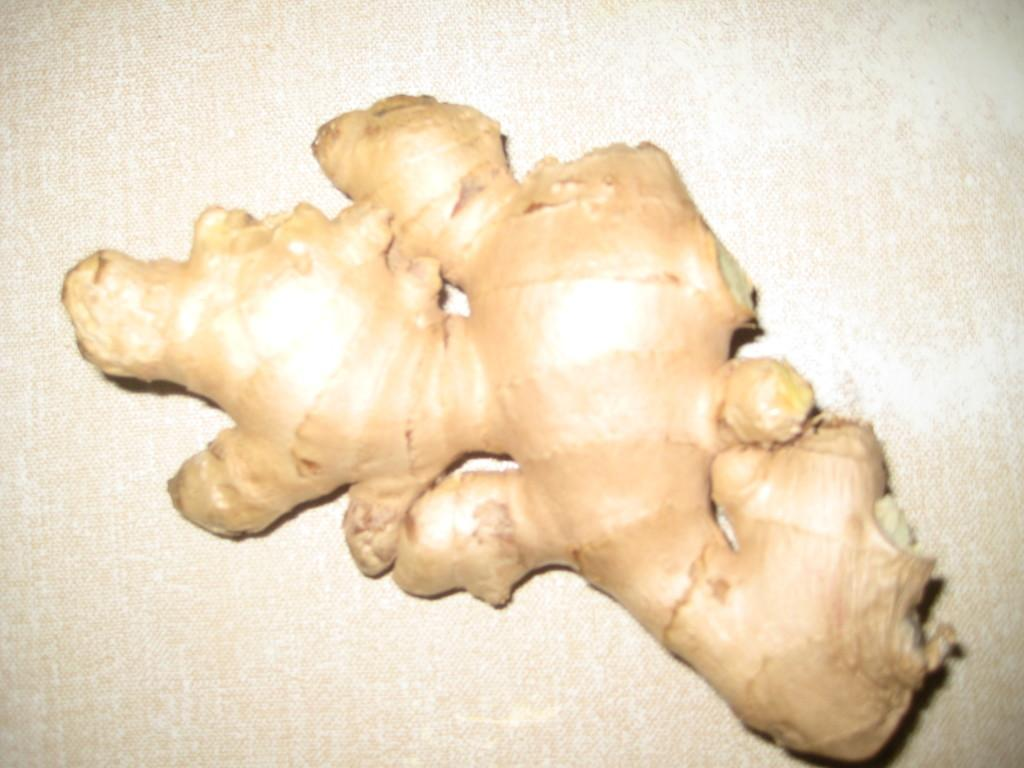What is present on the surface in the image? There is ginger on the surface in the image. Is there any evidence of a slave or poison in the image? No, there is no mention of a slave or poison in the image; it only features ginger on the surface. Can you tell me how many people are present in the image to help with the ginger? There is no indication of any people in the image, so it is not possible to determine how many might be present to help with the ginger. 